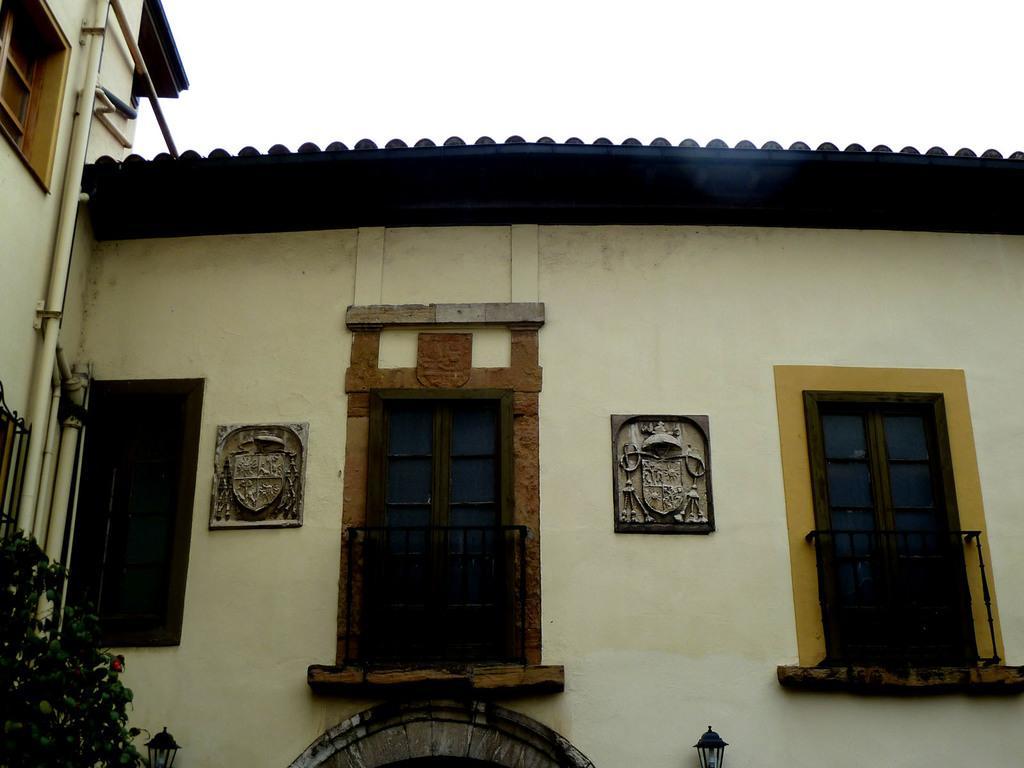How would you summarize this image in a sentence or two? In the picture we can see the house with two doors and beside the house we can see a part of the house with pipes and a part of the window in it and on the top of the house we can see a part of the sky. 